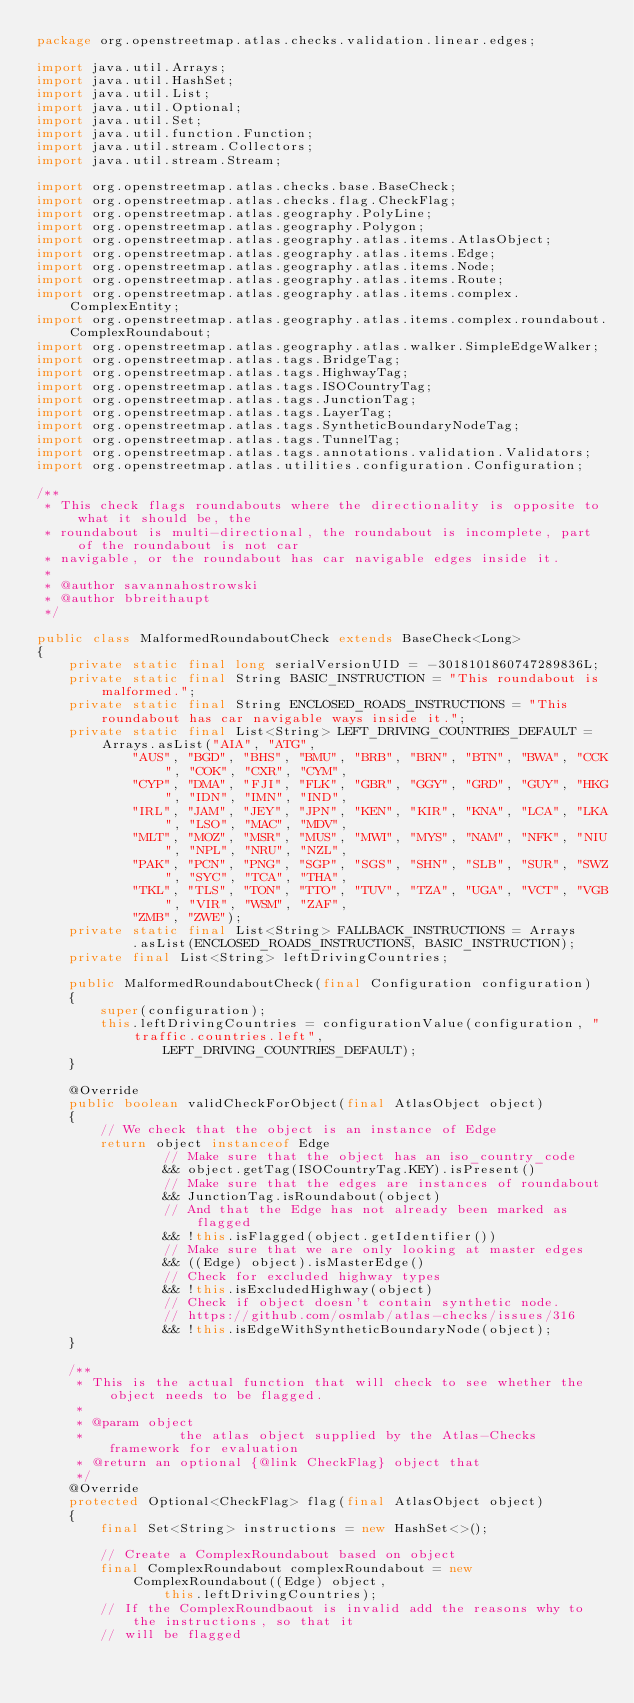<code> <loc_0><loc_0><loc_500><loc_500><_Java_>package org.openstreetmap.atlas.checks.validation.linear.edges;

import java.util.Arrays;
import java.util.HashSet;
import java.util.List;
import java.util.Optional;
import java.util.Set;
import java.util.function.Function;
import java.util.stream.Collectors;
import java.util.stream.Stream;

import org.openstreetmap.atlas.checks.base.BaseCheck;
import org.openstreetmap.atlas.checks.flag.CheckFlag;
import org.openstreetmap.atlas.geography.PolyLine;
import org.openstreetmap.atlas.geography.Polygon;
import org.openstreetmap.atlas.geography.atlas.items.AtlasObject;
import org.openstreetmap.atlas.geography.atlas.items.Edge;
import org.openstreetmap.atlas.geography.atlas.items.Node;
import org.openstreetmap.atlas.geography.atlas.items.Route;
import org.openstreetmap.atlas.geography.atlas.items.complex.ComplexEntity;
import org.openstreetmap.atlas.geography.atlas.items.complex.roundabout.ComplexRoundabout;
import org.openstreetmap.atlas.geography.atlas.walker.SimpleEdgeWalker;
import org.openstreetmap.atlas.tags.BridgeTag;
import org.openstreetmap.atlas.tags.HighwayTag;
import org.openstreetmap.atlas.tags.ISOCountryTag;
import org.openstreetmap.atlas.tags.JunctionTag;
import org.openstreetmap.atlas.tags.LayerTag;
import org.openstreetmap.atlas.tags.SyntheticBoundaryNodeTag;
import org.openstreetmap.atlas.tags.TunnelTag;
import org.openstreetmap.atlas.tags.annotations.validation.Validators;
import org.openstreetmap.atlas.utilities.configuration.Configuration;

/**
 * This check flags roundabouts where the directionality is opposite to what it should be, the
 * roundabout is multi-directional, the roundabout is incomplete, part of the roundabout is not car
 * navigable, or the roundabout has car navigable edges inside it.
 *
 * @author savannahostrowski
 * @author bbreithaupt
 */

public class MalformedRoundaboutCheck extends BaseCheck<Long>
{
    private static final long serialVersionUID = -3018101860747289836L;
    private static final String BASIC_INSTRUCTION = "This roundabout is malformed.";
    private static final String ENCLOSED_ROADS_INSTRUCTIONS = "This roundabout has car navigable ways inside it.";
    private static final List<String> LEFT_DRIVING_COUNTRIES_DEFAULT = Arrays.asList("AIA", "ATG",
            "AUS", "BGD", "BHS", "BMU", "BRB", "BRN", "BTN", "BWA", "CCK", "COK", "CXR", "CYM",
            "CYP", "DMA", "FJI", "FLK", "GBR", "GGY", "GRD", "GUY", "HKG", "IDN", "IMN", "IND",
            "IRL", "JAM", "JEY", "JPN", "KEN", "KIR", "KNA", "LCA", "LKA", "LSO", "MAC", "MDV",
            "MLT", "MOZ", "MSR", "MUS", "MWI", "MYS", "NAM", "NFK", "NIU", "NPL", "NRU", "NZL",
            "PAK", "PCN", "PNG", "SGP", "SGS", "SHN", "SLB", "SUR", "SWZ", "SYC", "TCA", "THA",
            "TKL", "TLS", "TON", "TTO", "TUV", "TZA", "UGA", "VCT", "VGB", "VIR", "WSM", "ZAF",
            "ZMB", "ZWE");
    private static final List<String> FALLBACK_INSTRUCTIONS = Arrays
            .asList(ENCLOSED_ROADS_INSTRUCTIONS, BASIC_INSTRUCTION);
    private final List<String> leftDrivingCountries;

    public MalformedRoundaboutCheck(final Configuration configuration)
    {
        super(configuration);
        this.leftDrivingCountries = configurationValue(configuration, "traffic.countries.left",
                LEFT_DRIVING_COUNTRIES_DEFAULT);
    }

    @Override
    public boolean validCheckForObject(final AtlasObject object)
    {
        // We check that the object is an instance of Edge
        return object instanceof Edge
                // Make sure that the object has an iso_country_code
                && object.getTag(ISOCountryTag.KEY).isPresent()
                // Make sure that the edges are instances of roundabout
                && JunctionTag.isRoundabout(object)
                // And that the Edge has not already been marked as flagged
                && !this.isFlagged(object.getIdentifier())
                // Make sure that we are only looking at master edges
                && ((Edge) object).isMasterEdge()
                // Check for excluded highway types
                && !this.isExcludedHighway(object)
                // Check if object doesn't contain synthetic node.
                // https://github.com/osmlab/atlas-checks/issues/316
                && !this.isEdgeWithSyntheticBoundaryNode(object);
    }

    /**
     * This is the actual function that will check to see whether the object needs to be flagged.
     *
     * @param object
     *            the atlas object supplied by the Atlas-Checks framework for evaluation
     * @return an optional {@link CheckFlag} object that
     */
    @Override
    protected Optional<CheckFlag> flag(final AtlasObject object)
    {
        final Set<String> instructions = new HashSet<>();

        // Create a ComplexRoundabout based on object
        final ComplexRoundabout complexRoundabout = new ComplexRoundabout((Edge) object,
                this.leftDrivingCountries);
        // If the ComplexRoundbaout is invalid add the reasons why to the instructions, so that it
        // will be flagged</code> 